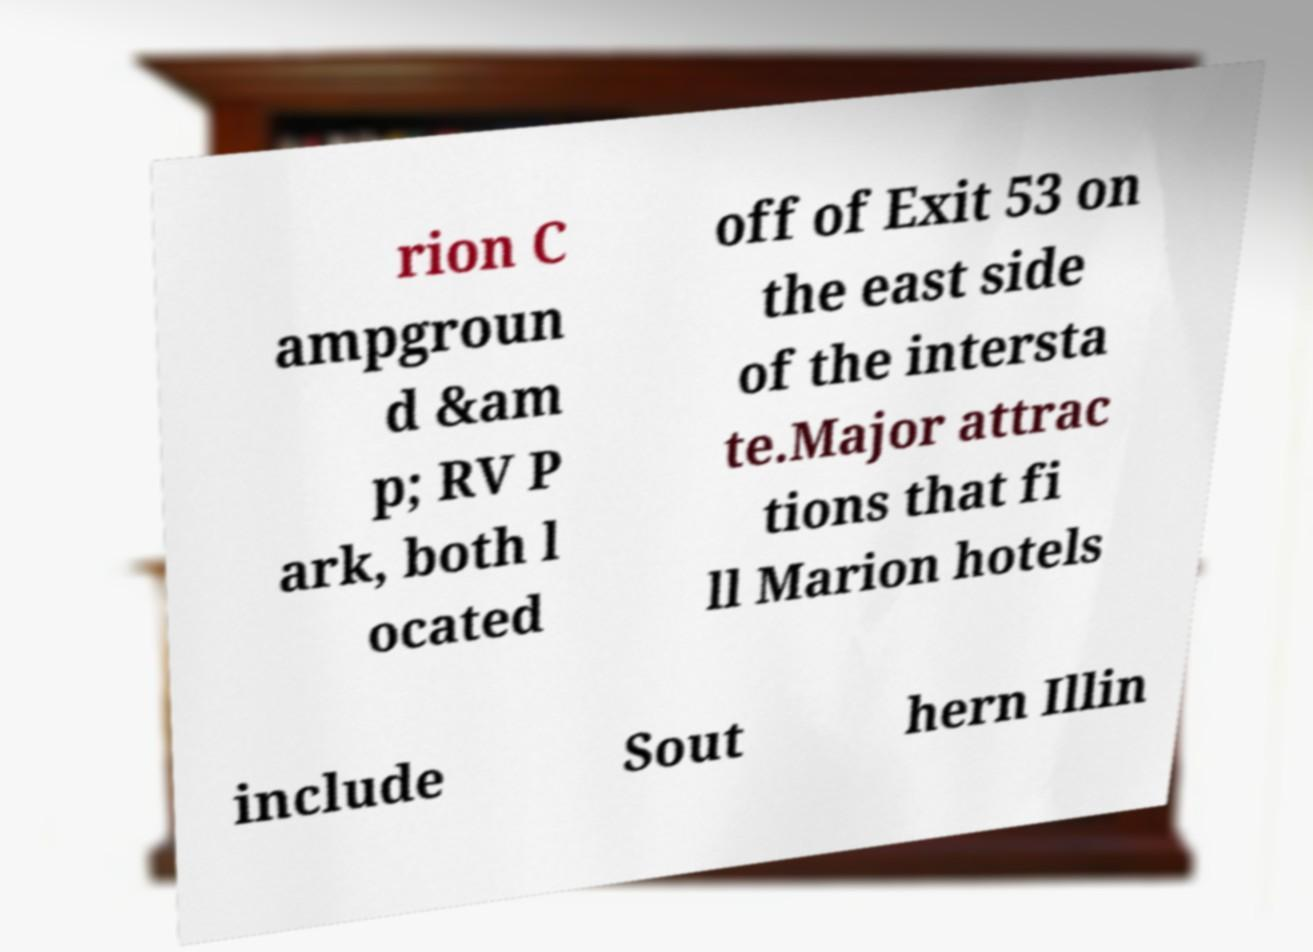Can you accurately transcribe the text from the provided image for me? rion C ampgroun d &am p; RV P ark, both l ocated off of Exit 53 on the east side of the intersta te.Major attrac tions that fi ll Marion hotels include Sout hern Illin 